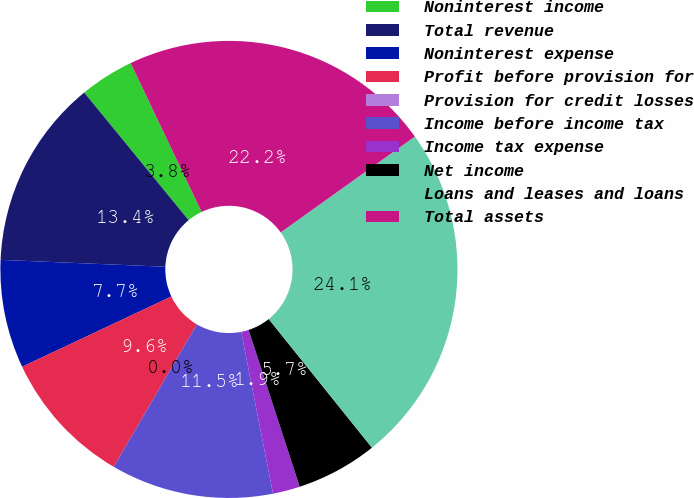Convert chart to OTSL. <chart><loc_0><loc_0><loc_500><loc_500><pie_chart><fcel>Noninterest income<fcel>Total revenue<fcel>Noninterest expense<fcel>Profit before provision for<fcel>Provision for credit losses<fcel>Income before income tax<fcel>Income tax expense<fcel>Net income<fcel>Loans and leases and loans<fcel>Total assets<nl><fcel>3.84%<fcel>13.42%<fcel>7.67%<fcel>9.59%<fcel>0.0%<fcel>11.5%<fcel>1.92%<fcel>5.75%<fcel>24.12%<fcel>22.2%<nl></chart> 